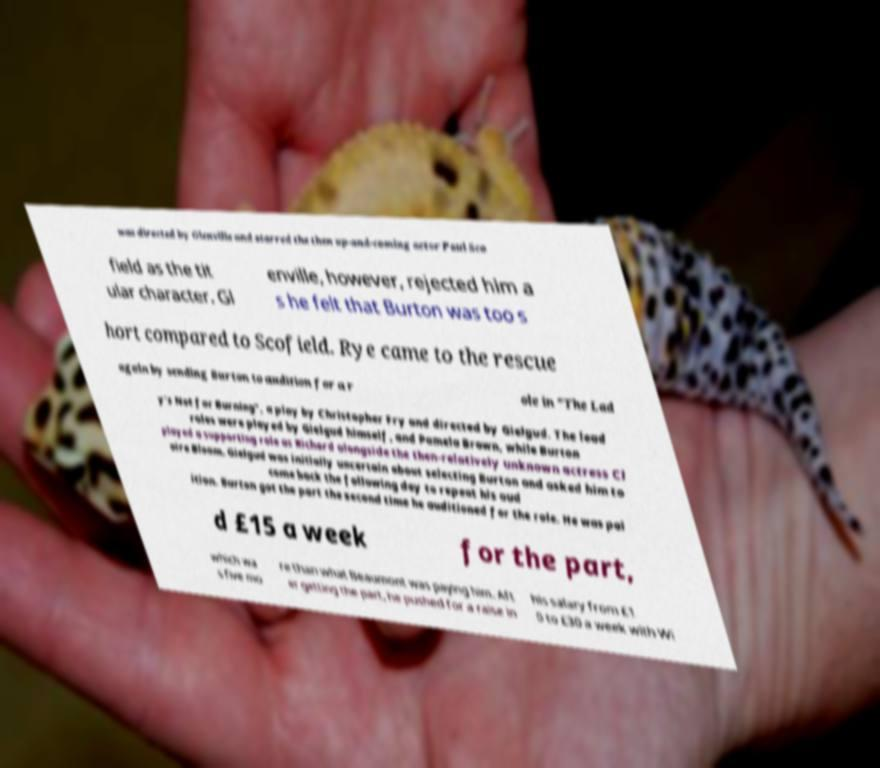For documentation purposes, I need the text within this image transcribed. Could you provide that? was directed by Glenville and starred the then up-and-coming actor Paul Sco field as the tit ular character. Gl enville, however, rejected him a s he felt that Burton was too s hort compared to Scofield. Rye came to the rescue again by sending Burton to audition for a r ole in "The Lad y's Not for Burning", a play by Christopher Fry and directed by Gielgud. The lead roles were played by Gielgud himself, and Pamela Brown, while Burton played a supporting role as Richard alongside the then-relatively unknown actress Cl aire Bloom. Gielgud was initially uncertain about selecting Burton and asked him to come back the following day to repeat his aud ition. Burton got the part the second time he auditioned for the role. He was pai d £15 a week for the part, which wa s five mo re than what Beaumont was paying him. Aft er getting the part, he pushed for a raise in his salary from £1 0 to £30 a week with Wi 